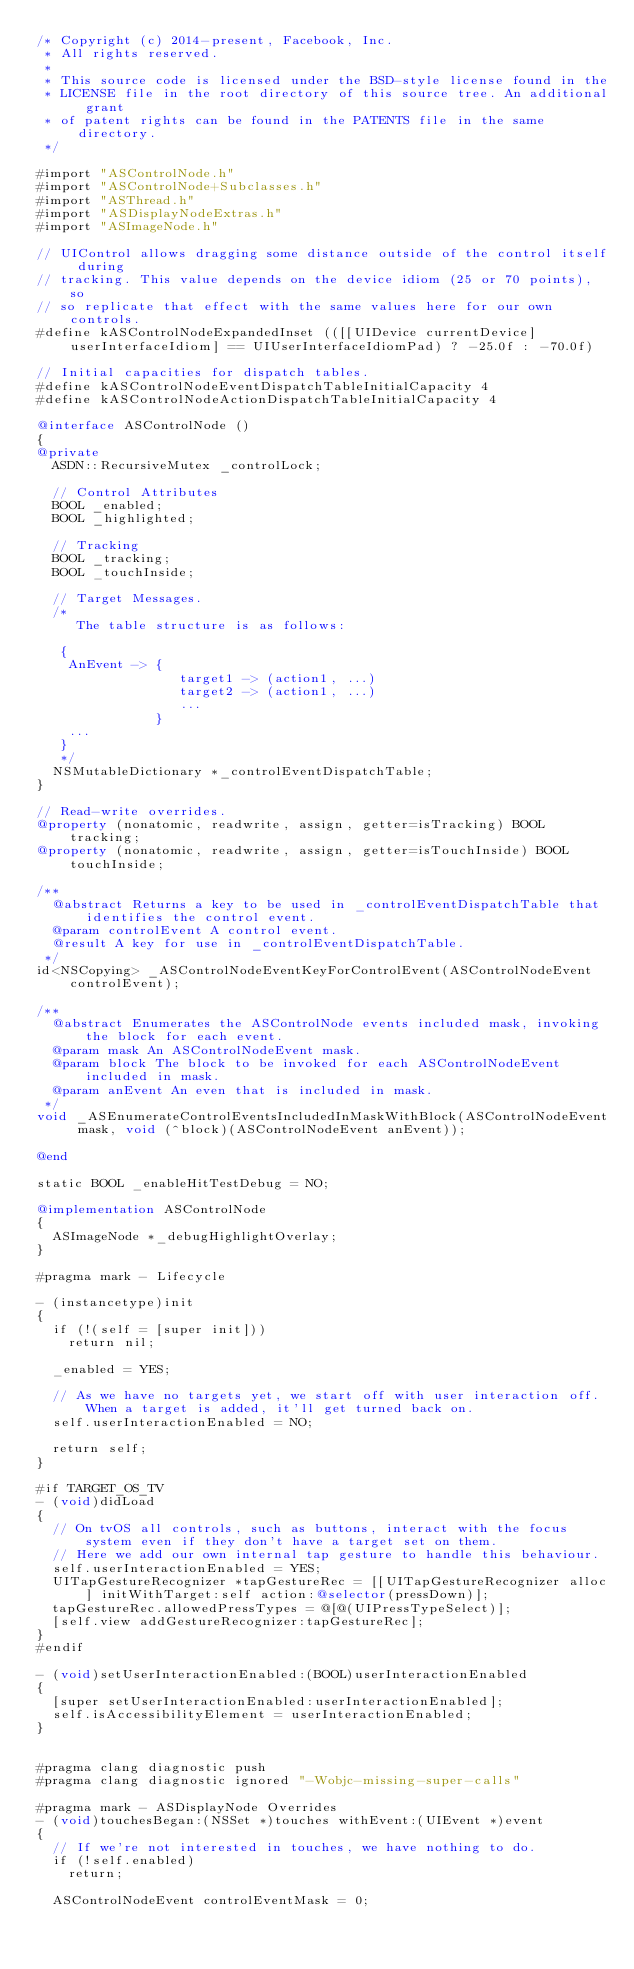Convert code to text. <code><loc_0><loc_0><loc_500><loc_500><_ObjectiveC_>/* Copyright (c) 2014-present, Facebook, Inc.
 * All rights reserved.
 *
 * This source code is licensed under the BSD-style license found in the
 * LICENSE file in the root directory of this source tree. An additional grant
 * of patent rights can be found in the PATENTS file in the same directory.
 */

#import "ASControlNode.h"
#import "ASControlNode+Subclasses.h"
#import "ASThread.h"
#import "ASDisplayNodeExtras.h"
#import "ASImageNode.h"

// UIControl allows dragging some distance outside of the control itself during
// tracking. This value depends on the device idiom (25 or 70 points), so
// so replicate that effect with the same values here for our own controls.
#define kASControlNodeExpandedInset (([[UIDevice currentDevice] userInterfaceIdiom] == UIUserInterfaceIdiomPad) ? -25.0f : -70.0f)

// Initial capacities for dispatch tables.
#define kASControlNodeEventDispatchTableInitialCapacity 4
#define kASControlNodeActionDispatchTableInitialCapacity 4

@interface ASControlNode ()
{
@private
  ASDN::RecursiveMutex _controlLock;
  
  // Control Attributes
  BOOL _enabled;
  BOOL _highlighted;

  // Tracking
  BOOL _tracking;
  BOOL _touchInside;

  // Target Messages.
  /*
     The table structure is as follows:

   {
    AnEvent -> {
                  target1 -> (action1, ...)
                  target2 -> (action1, ...)
                  ...
               }
    ...
   }
   */
  NSMutableDictionary *_controlEventDispatchTable;
}

// Read-write overrides.
@property (nonatomic, readwrite, assign, getter=isTracking) BOOL tracking;
@property (nonatomic, readwrite, assign, getter=isTouchInside) BOOL touchInside;

/**
  @abstract Returns a key to be used in _controlEventDispatchTable that identifies the control event.
  @param controlEvent A control event.
  @result A key for use in _controlEventDispatchTable.
 */
id<NSCopying> _ASControlNodeEventKeyForControlEvent(ASControlNodeEvent controlEvent);

/**
  @abstract Enumerates the ASControlNode events included mask, invoking the block for each event.
  @param mask An ASControlNodeEvent mask.
  @param block The block to be invoked for each ASControlNodeEvent included in mask.
  @param anEvent An even that is included in mask.
 */
void _ASEnumerateControlEventsIncludedInMaskWithBlock(ASControlNodeEvent mask, void (^block)(ASControlNodeEvent anEvent));

@end

static BOOL _enableHitTestDebug = NO;

@implementation ASControlNode
{
  ASImageNode *_debugHighlightOverlay;
}

#pragma mark - Lifecycle

- (instancetype)init
{
  if (!(self = [super init]))
    return nil;

  _enabled = YES;

  // As we have no targets yet, we start off with user interaction off. When a target is added, it'll get turned back on.
  self.userInteractionEnabled = NO;
  
  return self;
}

#if TARGET_OS_TV
- (void)didLoad
{
  // On tvOS all controls, such as buttons, interact with the focus system even if they don't have a target set on them.
  // Here we add our own internal tap gesture to handle this behaviour.
  self.userInteractionEnabled = YES;
  UITapGestureRecognizer *tapGestureRec = [[UITapGestureRecognizer alloc] initWithTarget:self action:@selector(pressDown)];
  tapGestureRec.allowedPressTypes = @[@(UIPressTypeSelect)];
  [self.view addGestureRecognizer:tapGestureRec];
}
#endif

- (void)setUserInteractionEnabled:(BOOL)userInteractionEnabled
{
  [super setUserInteractionEnabled:userInteractionEnabled];
  self.isAccessibilityElement = userInteractionEnabled;
}


#pragma clang diagnostic push
#pragma clang diagnostic ignored "-Wobjc-missing-super-calls"

#pragma mark - ASDisplayNode Overrides
- (void)touchesBegan:(NSSet *)touches withEvent:(UIEvent *)event
{
  // If we're not interested in touches, we have nothing to do.
  if (!self.enabled)
    return;

  ASControlNodeEvent controlEventMask = 0;
</code> 